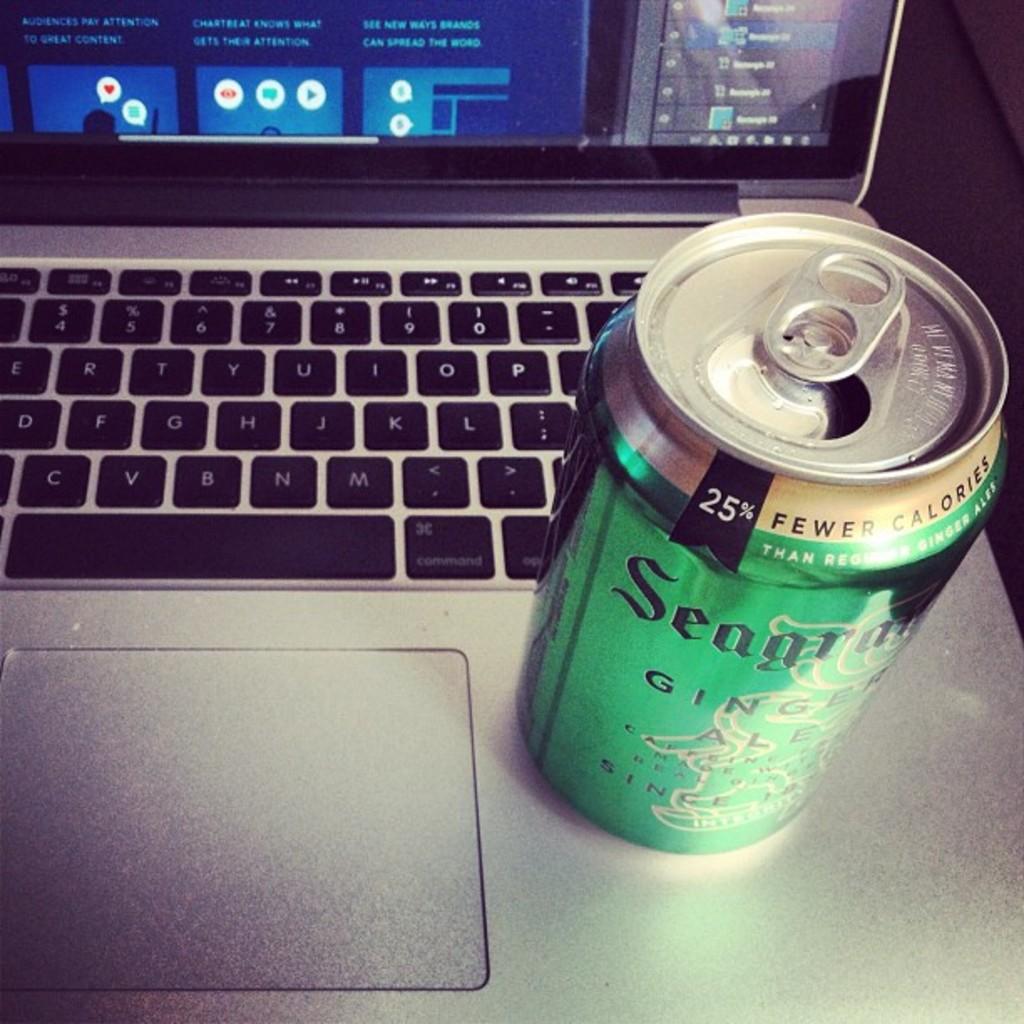What percentage of fewer calories does the drink contain compared to the regular?
Your answer should be compact. 25. 